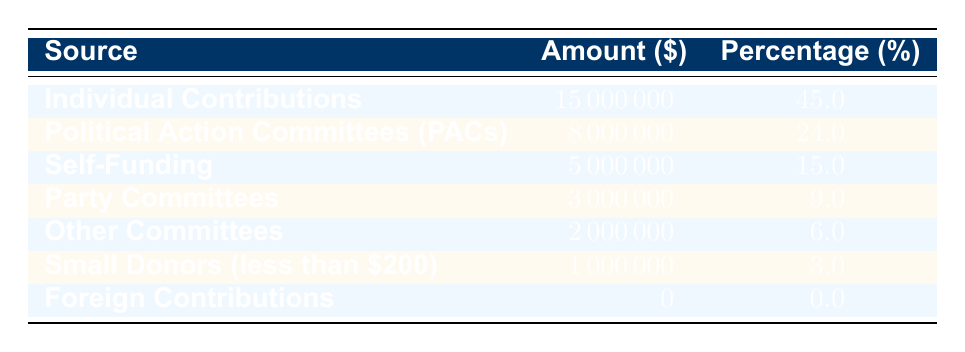What is the amount obtained from Individual Contributions? According to the table, the amount for Individual Contributions is specifically listed as 15,000,000.
Answer: 15,000,000 What percentage of total campaign donations came from Political Action Committees (PACs)? The table explicitly states that Political Action Committees contributed 24.0 percent of the total campaign donations.
Answer: 24.0 percent What is the total amount contributed by Party Committees and Other Committees combined? To find this, we sum the contributions from Party Committees (3,000,000) and Other Committees (2,000,000). Adding these together gives us 3,000,000 + 2,000,000 = 5,000,000.
Answer: 5,000,000 Did the campaign receive any Foreign Contributions? The table shows that the amount for Foreign Contributions is listed as 0, which means there were no contributions from this source.
Answer: No Which source contributed more: Self-Funding or Small Donors (less than 200)? Comparing the amounts, Self-Funding contributed 5,000,000 and Small Donors contributed only 1,000,000. Since 5,000,000 is greater than 1,000,000, Self-Funding contributed more.
Answer: Self-Funding What is the average contribution amount across all sources? First, we add all contributions: 15,000,000 + 8,000,000 + 5,000,000 + 3,000,000 + 2,000,000 + 1,000,000 + 0 = 34,000,000. Then, we count the number of sources, which is 7. Finally, we divide the total amount by the number of sources: 34,000,000 / 7 = 4,857,142.86.
Answer: 4,857,142.86 Is it true that more than half of the contributions came from Individual Contributions? The percentage of contributions from Individual Contributions is 45.0, which is less than half (50.0 percent). Therefore, it is not true that more than half came from this source.
Answer: No Which contribution source had the lowest amount? According to the table, Foreign Contributions had the lowest amount with a contribution of 0.
Answer: Foreign Contributions 